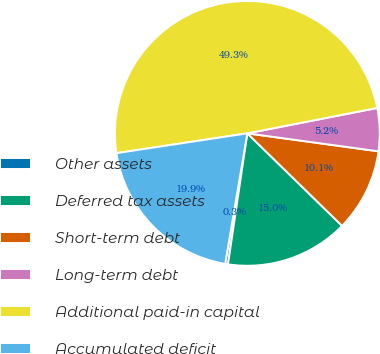<chart> <loc_0><loc_0><loc_500><loc_500><pie_chart><fcel>Other assets<fcel>Deferred tax assets<fcel>Short-term debt<fcel>Long-term debt<fcel>Additional paid-in capital<fcel>Accumulated deficit<nl><fcel>0.34%<fcel>15.03%<fcel>10.14%<fcel>5.24%<fcel>49.32%<fcel>19.93%<nl></chart> 